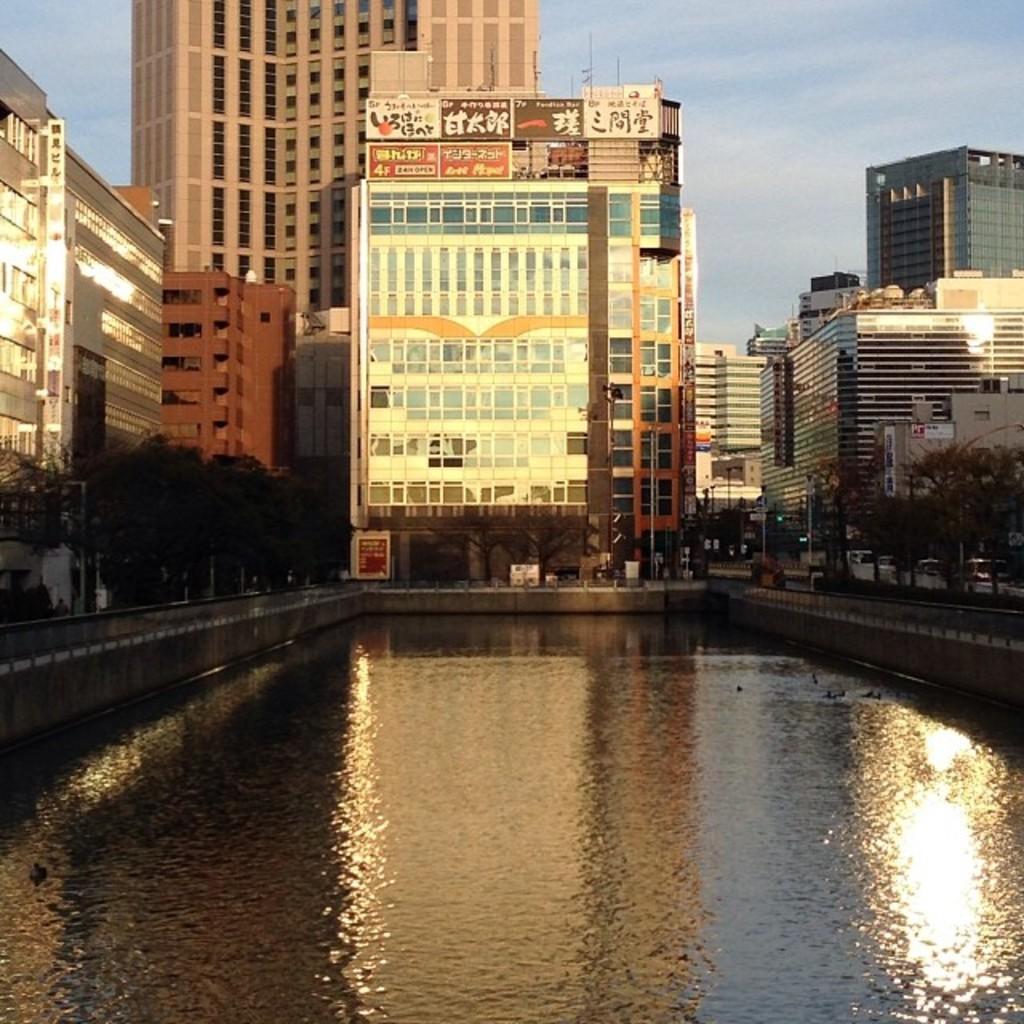Can you describe this image briefly? In the picture we can see water around it, we can see fencing and trees and behind it, we can see buildings and some hoardings on the top of it and behind it we can see a sky with clouds. 